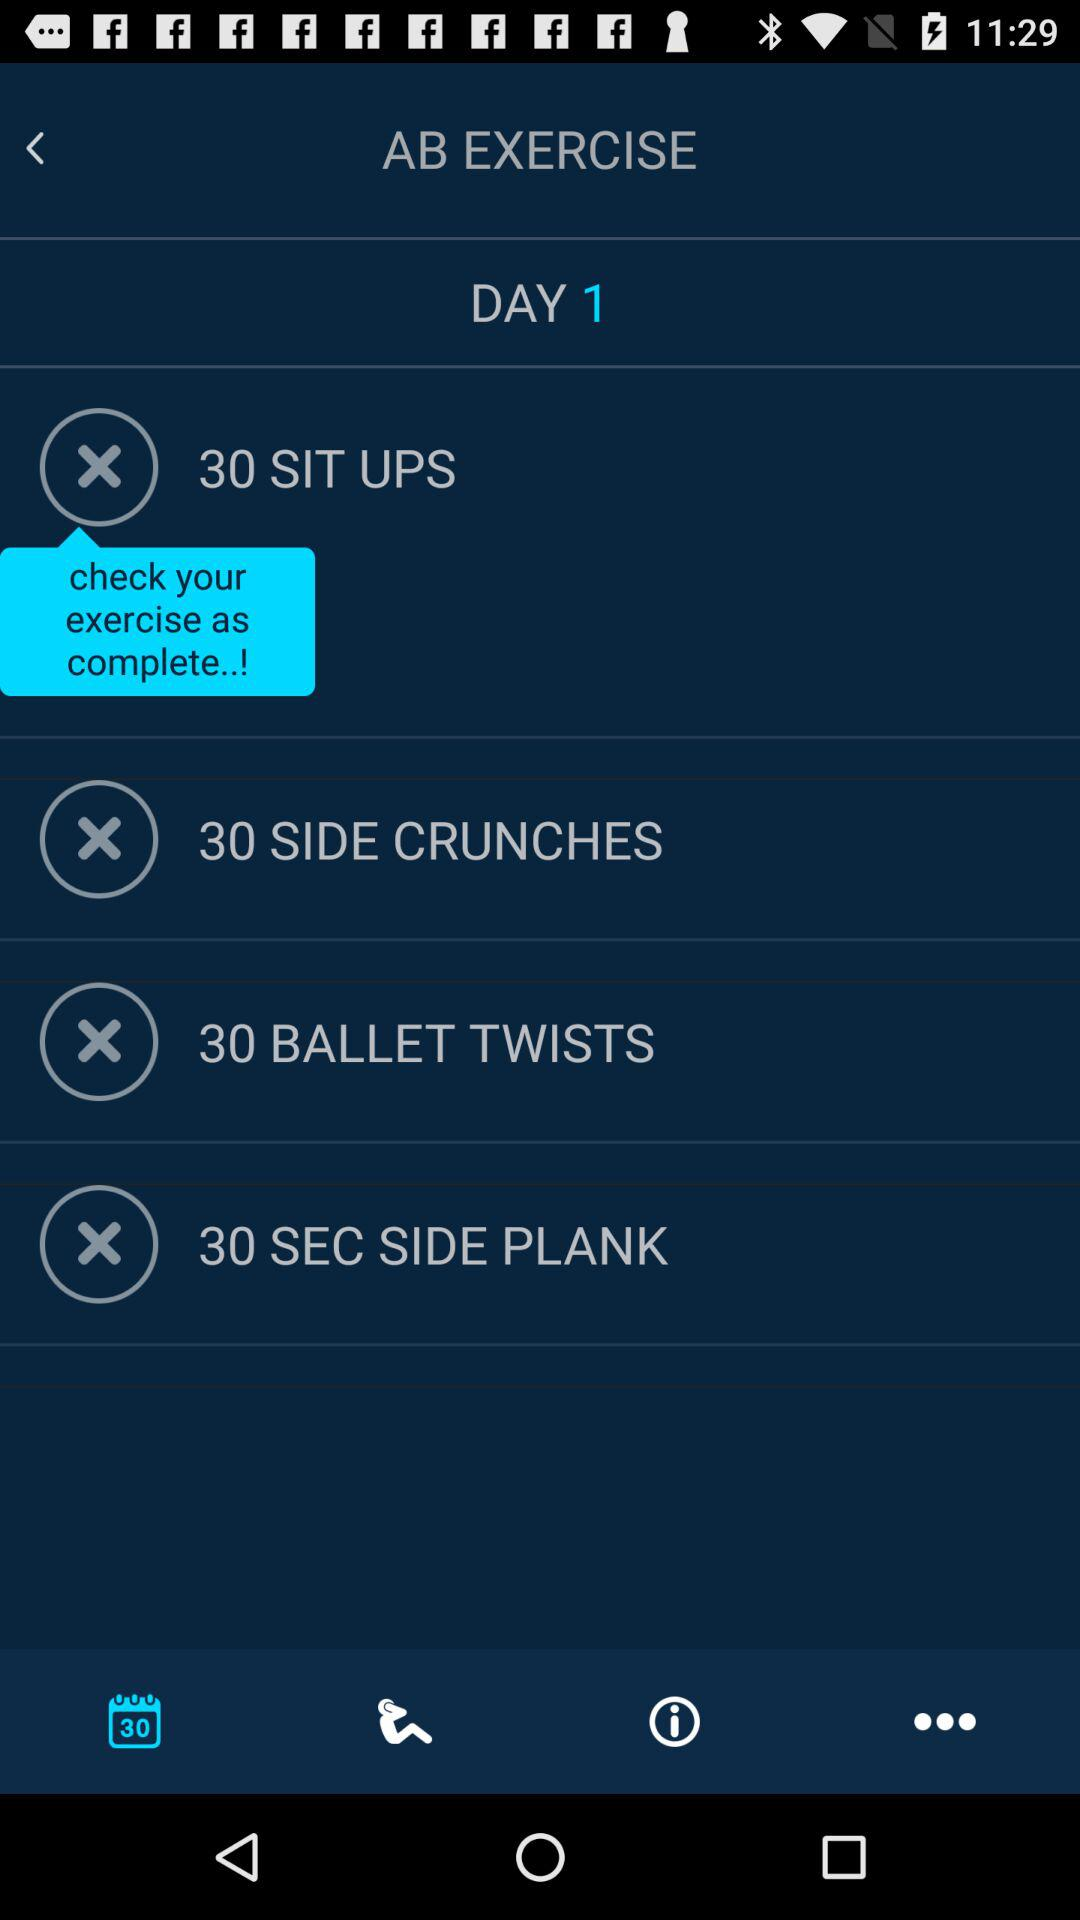How many sit ups are there in total?
Answer the question using a single word or phrase. 30 